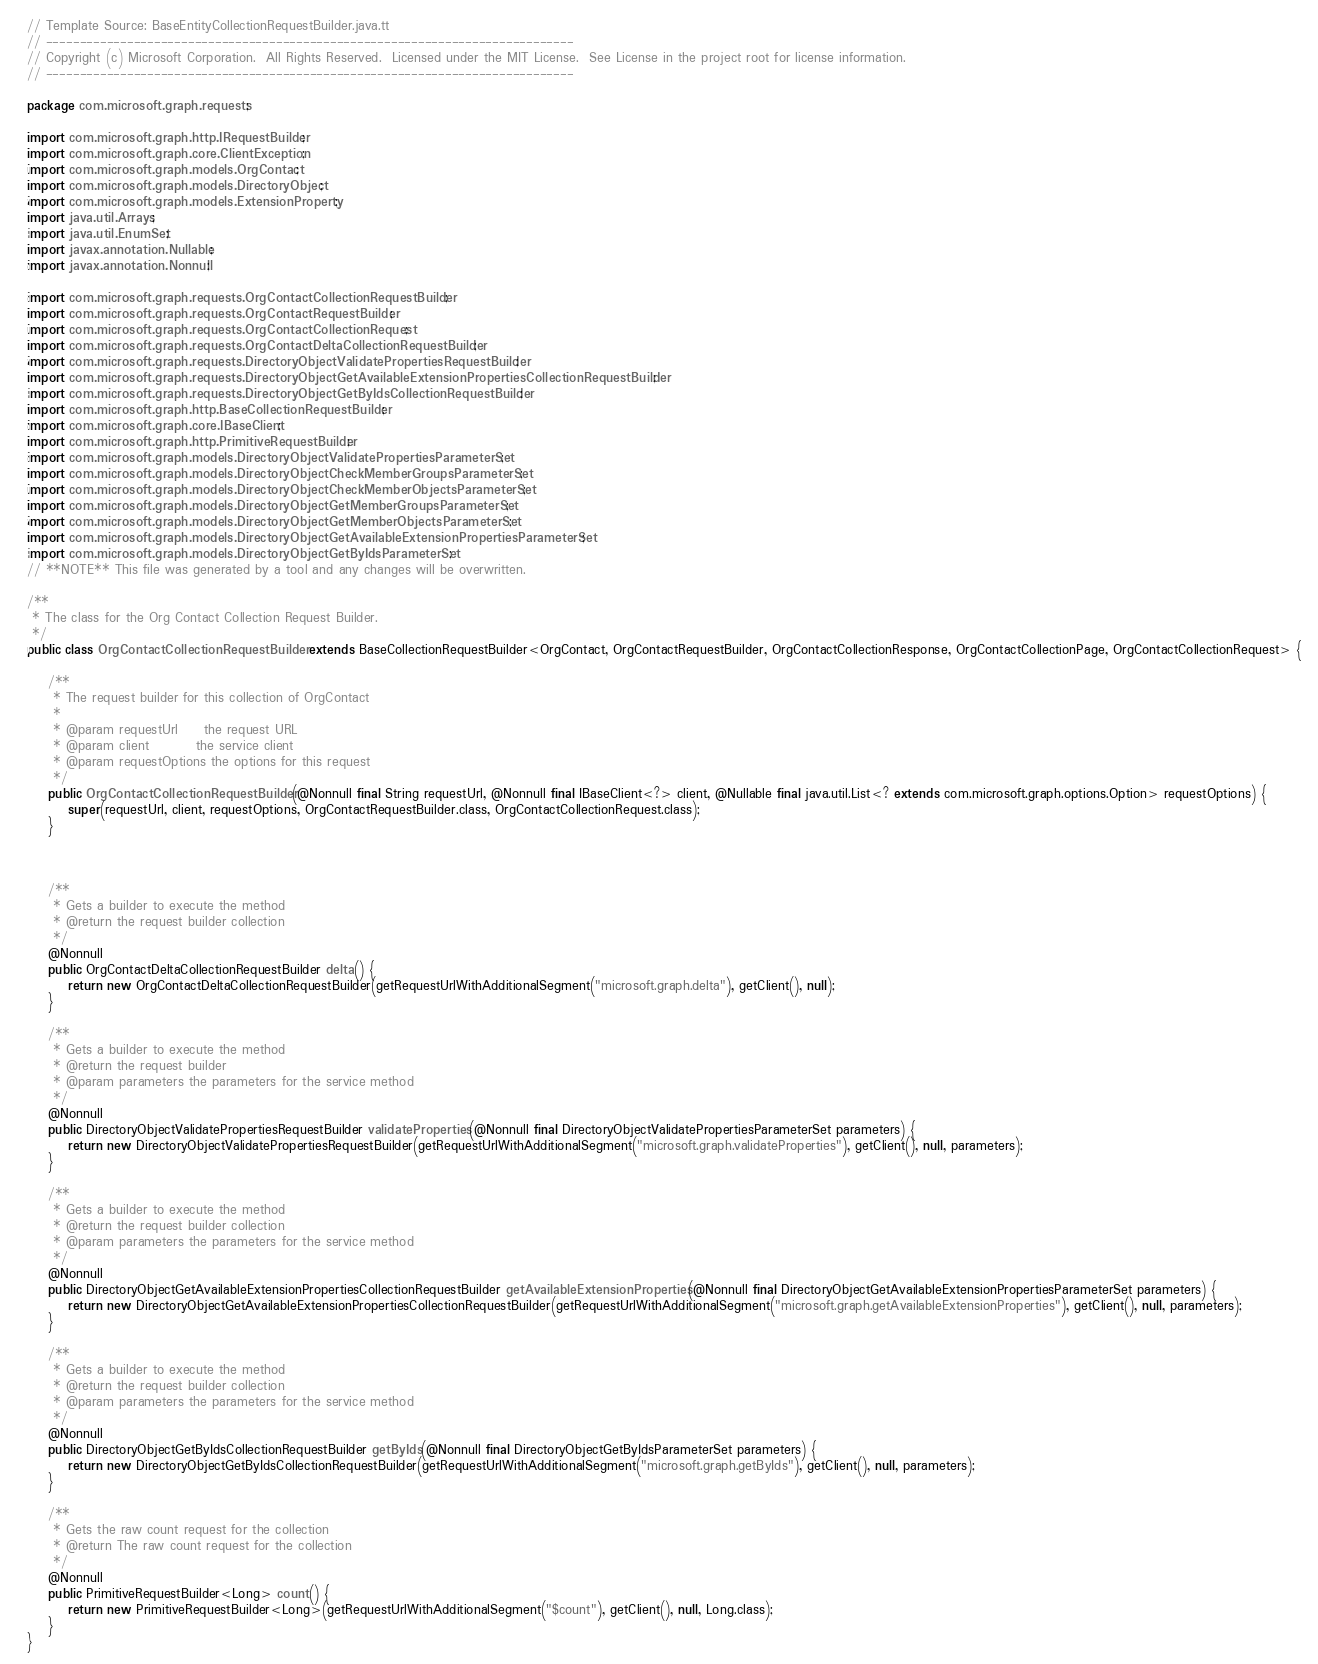Convert code to text. <code><loc_0><loc_0><loc_500><loc_500><_Java_>// Template Source: BaseEntityCollectionRequestBuilder.java.tt
// ------------------------------------------------------------------------------
// Copyright (c) Microsoft Corporation.  All Rights Reserved.  Licensed under the MIT License.  See License in the project root for license information.
// ------------------------------------------------------------------------------

package com.microsoft.graph.requests;

import com.microsoft.graph.http.IRequestBuilder;
import com.microsoft.graph.core.ClientException;
import com.microsoft.graph.models.OrgContact;
import com.microsoft.graph.models.DirectoryObject;
import com.microsoft.graph.models.ExtensionProperty;
import java.util.Arrays;
import java.util.EnumSet;
import javax.annotation.Nullable;
import javax.annotation.Nonnull;

import com.microsoft.graph.requests.OrgContactCollectionRequestBuilder;
import com.microsoft.graph.requests.OrgContactRequestBuilder;
import com.microsoft.graph.requests.OrgContactCollectionRequest;
import com.microsoft.graph.requests.OrgContactDeltaCollectionRequestBuilder;
import com.microsoft.graph.requests.DirectoryObjectValidatePropertiesRequestBuilder;
import com.microsoft.graph.requests.DirectoryObjectGetAvailableExtensionPropertiesCollectionRequestBuilder;
import com.microsoft.graph.requests.DirectoryObjectGetByIdsCollectionRequestBuilder;
import com.microsoft.graph.http.BaseCollectionRequestBuilder;
import com.microsoft.graph.core.IBaseClient;
import com.microsoft.graph.http.PrimitiveRequestBuilder;
import com.microsoft.graph.models.DirectoryObjectValidatePropertiesParameterSet;
import com.microsoft.graph.models.DirectoryObjectCheckMemberGroupsParameterSet;
import com.microsoft.graph.models.DirectoryObjectCheckMemberObjectsParameterSet;
import com.microsoft.graph.models.DirectoryObjectGetMemberGroupsParameterSet;
import com.microsoft.graph.models.DirectoryObjectGetMemberObjectsParameterSet;
import com.microsoft.graph.models.DirectoryObjectGetAvailableExtensionPropertiesParameterSet;
import com.microsoft.graph.models.DirectoryObjectGetByIdsParameterSet;
// **NOTE** This file was generated by a tool and any changes will be overwritten.

/**
 * The class for the Org Contact Collection Request Builder.
 */
public class OrgContactCollectionRequestBuilder extends BaseCollectionRequestBuilder<OrgContact, OrgContactRequestBuilder, OrgContactCollectionResponse, OrgContactCollectionPage, OrgContactCollectionRequest> {

    /**
     * The request builder for this collection of OrgContact
     *
     * @param requestUrl     the request URL
     * @param client         the service client
     * @param requestOptions the options for this request
     */
    public OrgContactCollectionRequestBuilder(@Nonnull final String requestUrl, @Nonnull final IBaseClient<?> client, @Nullable final java.util.List<? extends com.microsoft.graph.options.Option> requestOptions) {
        super(requestUrl, client, requestOptions, OrgContactRequestBuilder.class, OrgContactCollectionRequest.class);
    }



    /**
     * Gets a builder to execute the method
     * @return the request builder collection
     */
    @Nonnull
    public OrgContactDeltaCollectionRequestBuilder delta() {
        return new OrgContactDeltaCollectionRequestBuilder(getRequestUrlWithAdditionalSegment("microsoft.graph.delta"), getClient(), null);
    }

    /**
     * Gets a builder to execute the method
     * @return the request builder
     * @param parameters the parameters for the service method
     */
    @Nonnull
    public DirectoryObjectValidatePropertiesRequestBuilder validateProperties(@Nonnull final DirectoryObjectValidatePropertiesParameterSet parameters) {
        return new DirectoryObjectValidatePropertiesRequestBuilder(getRequestUrlWithAdditionalSegment("microsoft.graph.validateProperties"), getClient(), null, parameters);
    }

    /**
     * Gets a builder to execute the method
     * @return the request builder collection
     * @param parameters the parameters for the service method
     */
    @Nonnull
    public DirectoryObjectGetAvailableExtensionPropertiesCollectionRequestBuilder getAvailableExtensionProperties(@Nonnull final DirectoryObjectGetAvailableExtensionPropertiesParameterSet parameters) {
        return new DirectoryObjectGetAvailableExtensionPropertiesCollectionRequestBuilder(getRequestUrlWithAdditionalSegment("microsoft.graph.getAvailableExtensionProperties"), getClient(), null, parameters);
    }

    /**
     * Gets a builder to execute the method
     * @return the request builder collection
     * @param parameters the parameters for the service method
     */
    @Nonnull
    public DirectoryObjectGetByIdsCollectionRequestBuilder getByIds(@Nonnull final DirectoryObjectGetByIdsParameterSet parameters) {
        return new DirectoryObjectGetByIdsCollectionRequestBuilder(getRequestUrlWithAdditionalSegment("microsoft.graph.getByIds"), getClient(), null, parameters);
    }

    /**
     * Gets the raw count request for the collection
     * @return The raw count request for the collection
     */
    @Nonnull
    public PrimitiveRequestBuilder<Long> count() {
        return new PrimitiveRequestBuilder<Long>(getRequestUrlWithAdditionalSegment("$count"), getClient(), null, Long.class);
    }
}
</code> 